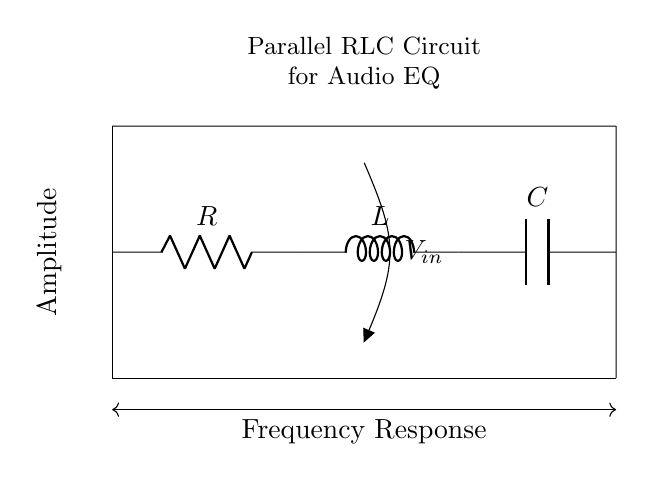What are the components in this circuit? The circuit contains a resistor (R), an inductor (L), and a capacitor (C), which are the three components typically found in an RLC circuit.
Answer: Resistor, Inductor, Capacitor What is the voltage input of this circuit? The circuit shows an input voltage labeled as V-in, meaning the supplied voltage is defined at that point.
Answer: V-in How many components are connected in parallel in this circuit? In this circuit, the resistor, inductor, and capacitor are connected in parallel, making a total of three components in parallel.
Answer: Three What is the purpose of this RLC circuit in audio systems? The parallel RLC circuit is used for audio equalization, which means it is designed to shape the frequency response of audio signals.
Answer: Audio equalization Which element would primarily affect the reactive response of this circuit? The inductor (L) is the element that primarily provides reactive impedance, influencing the circuit's frequency response in conjunction with the capacitor.
Answer: Inductor What happens to the frequency response when the resistance increases? Increasing resistance can dampen the circuit's response, reducing the peak amplitude at resonance and altering the quality factor, leading to a less sharp resonance.
Answer: Dampen response What type of circuit configuration is this? This is a parallel configuration, as evident from the layout of the components side by side rather than in a series.
Answer: Parallel configuration 